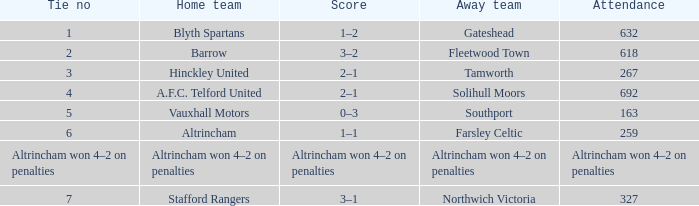Which home team had the away team Southport? Vauxhall Motors. 